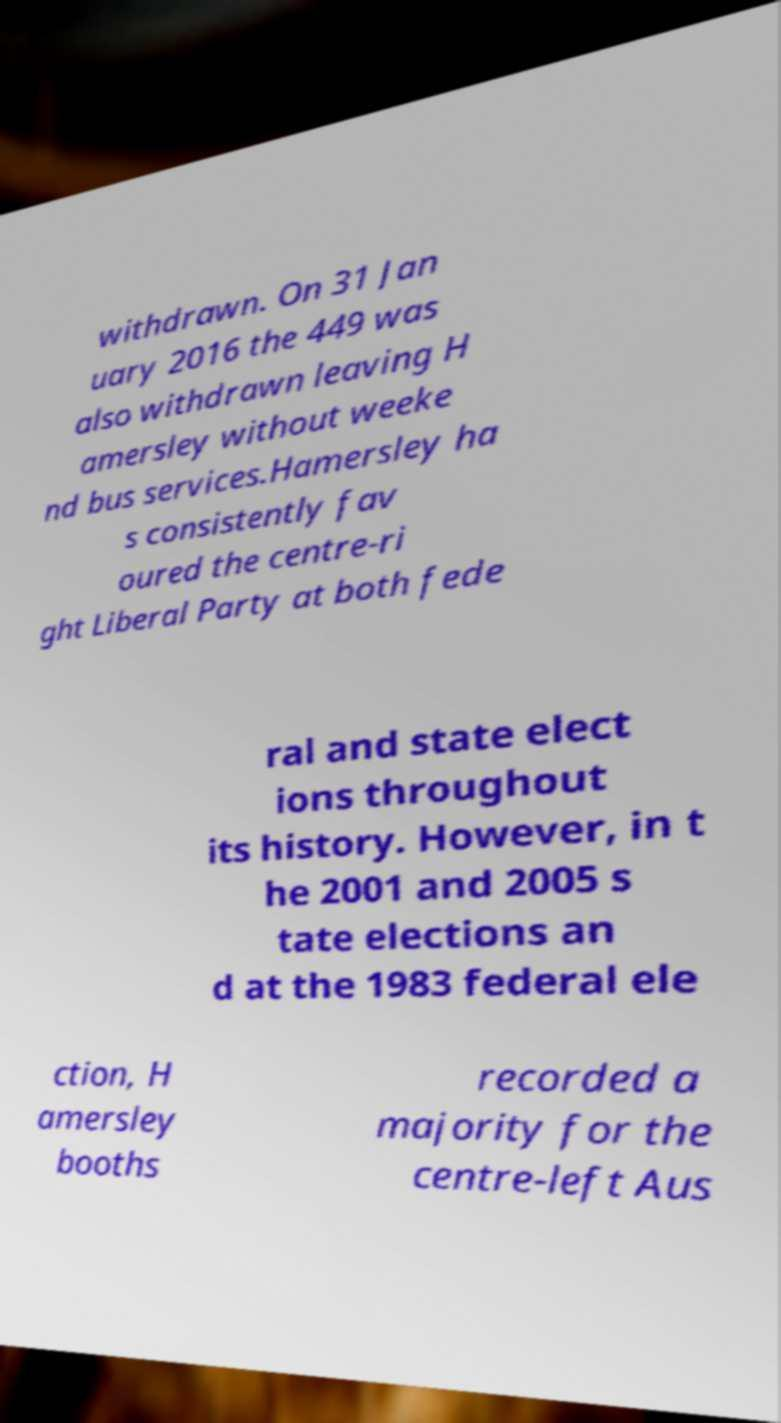Could you extract and type out the text from this image? withdrawn. On 31 Jan uary 2016 the 449 was also withdrawn leaving H amersley without weeke nd bus services.Hamersley ha s consistently fav oured the centre-ri ght Liberal Party at both fede ral and state elect ions throughout its history. However, in t he 2001 and 2005 s tate elections an d at the 1983 federal ele ction, H amersley booths recorded a majority for the centre-left Aus 